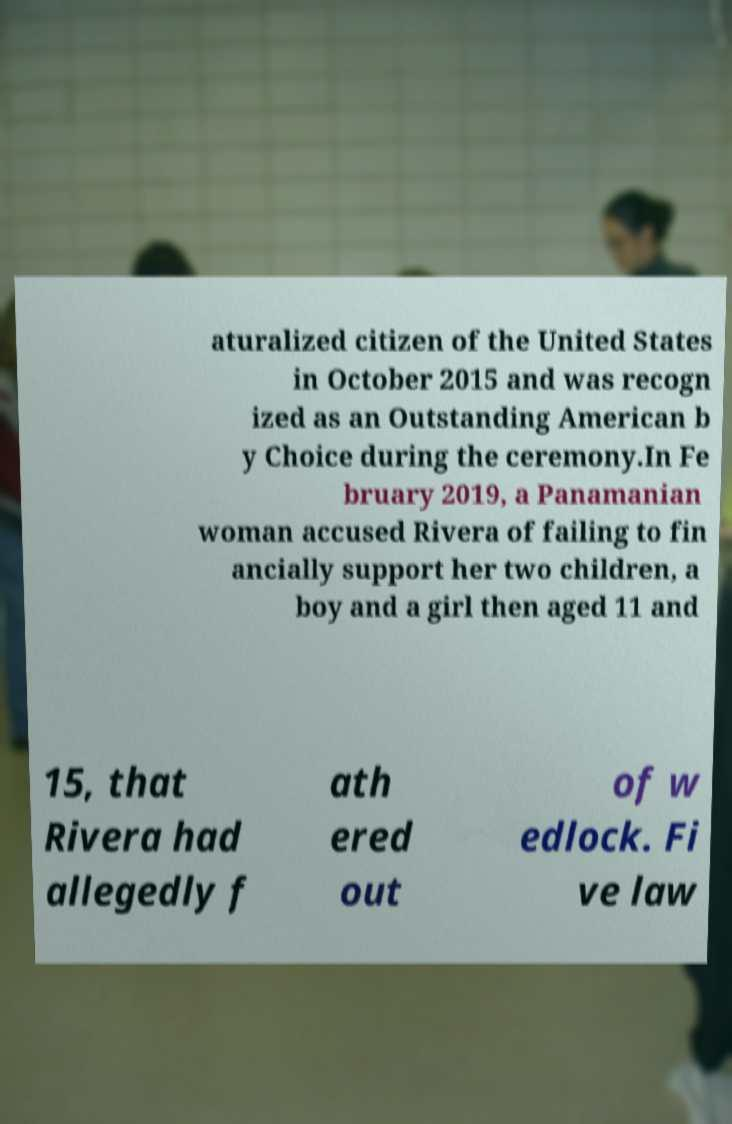Please read and relay the text visible in this image. What does it say? aturalized citizen of the United States in October 2015 and was recogn ized as an Outstanding American b y Choice during the ceremony.In Fe bruary 2019, a Panamanian woman accused Rivera of failing to fin ancially support her two children, a boy and a girl then aged 11 and 15, that Rivera had allegedly f ath ered out of w edlock. Fi ve law 